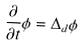Convert formula to latex. <formula><loc_0><loc_0><loc_500><loc_500>\frac { \partial } { \partial t } \phi = \Delta _ { d } \phi</formula> 